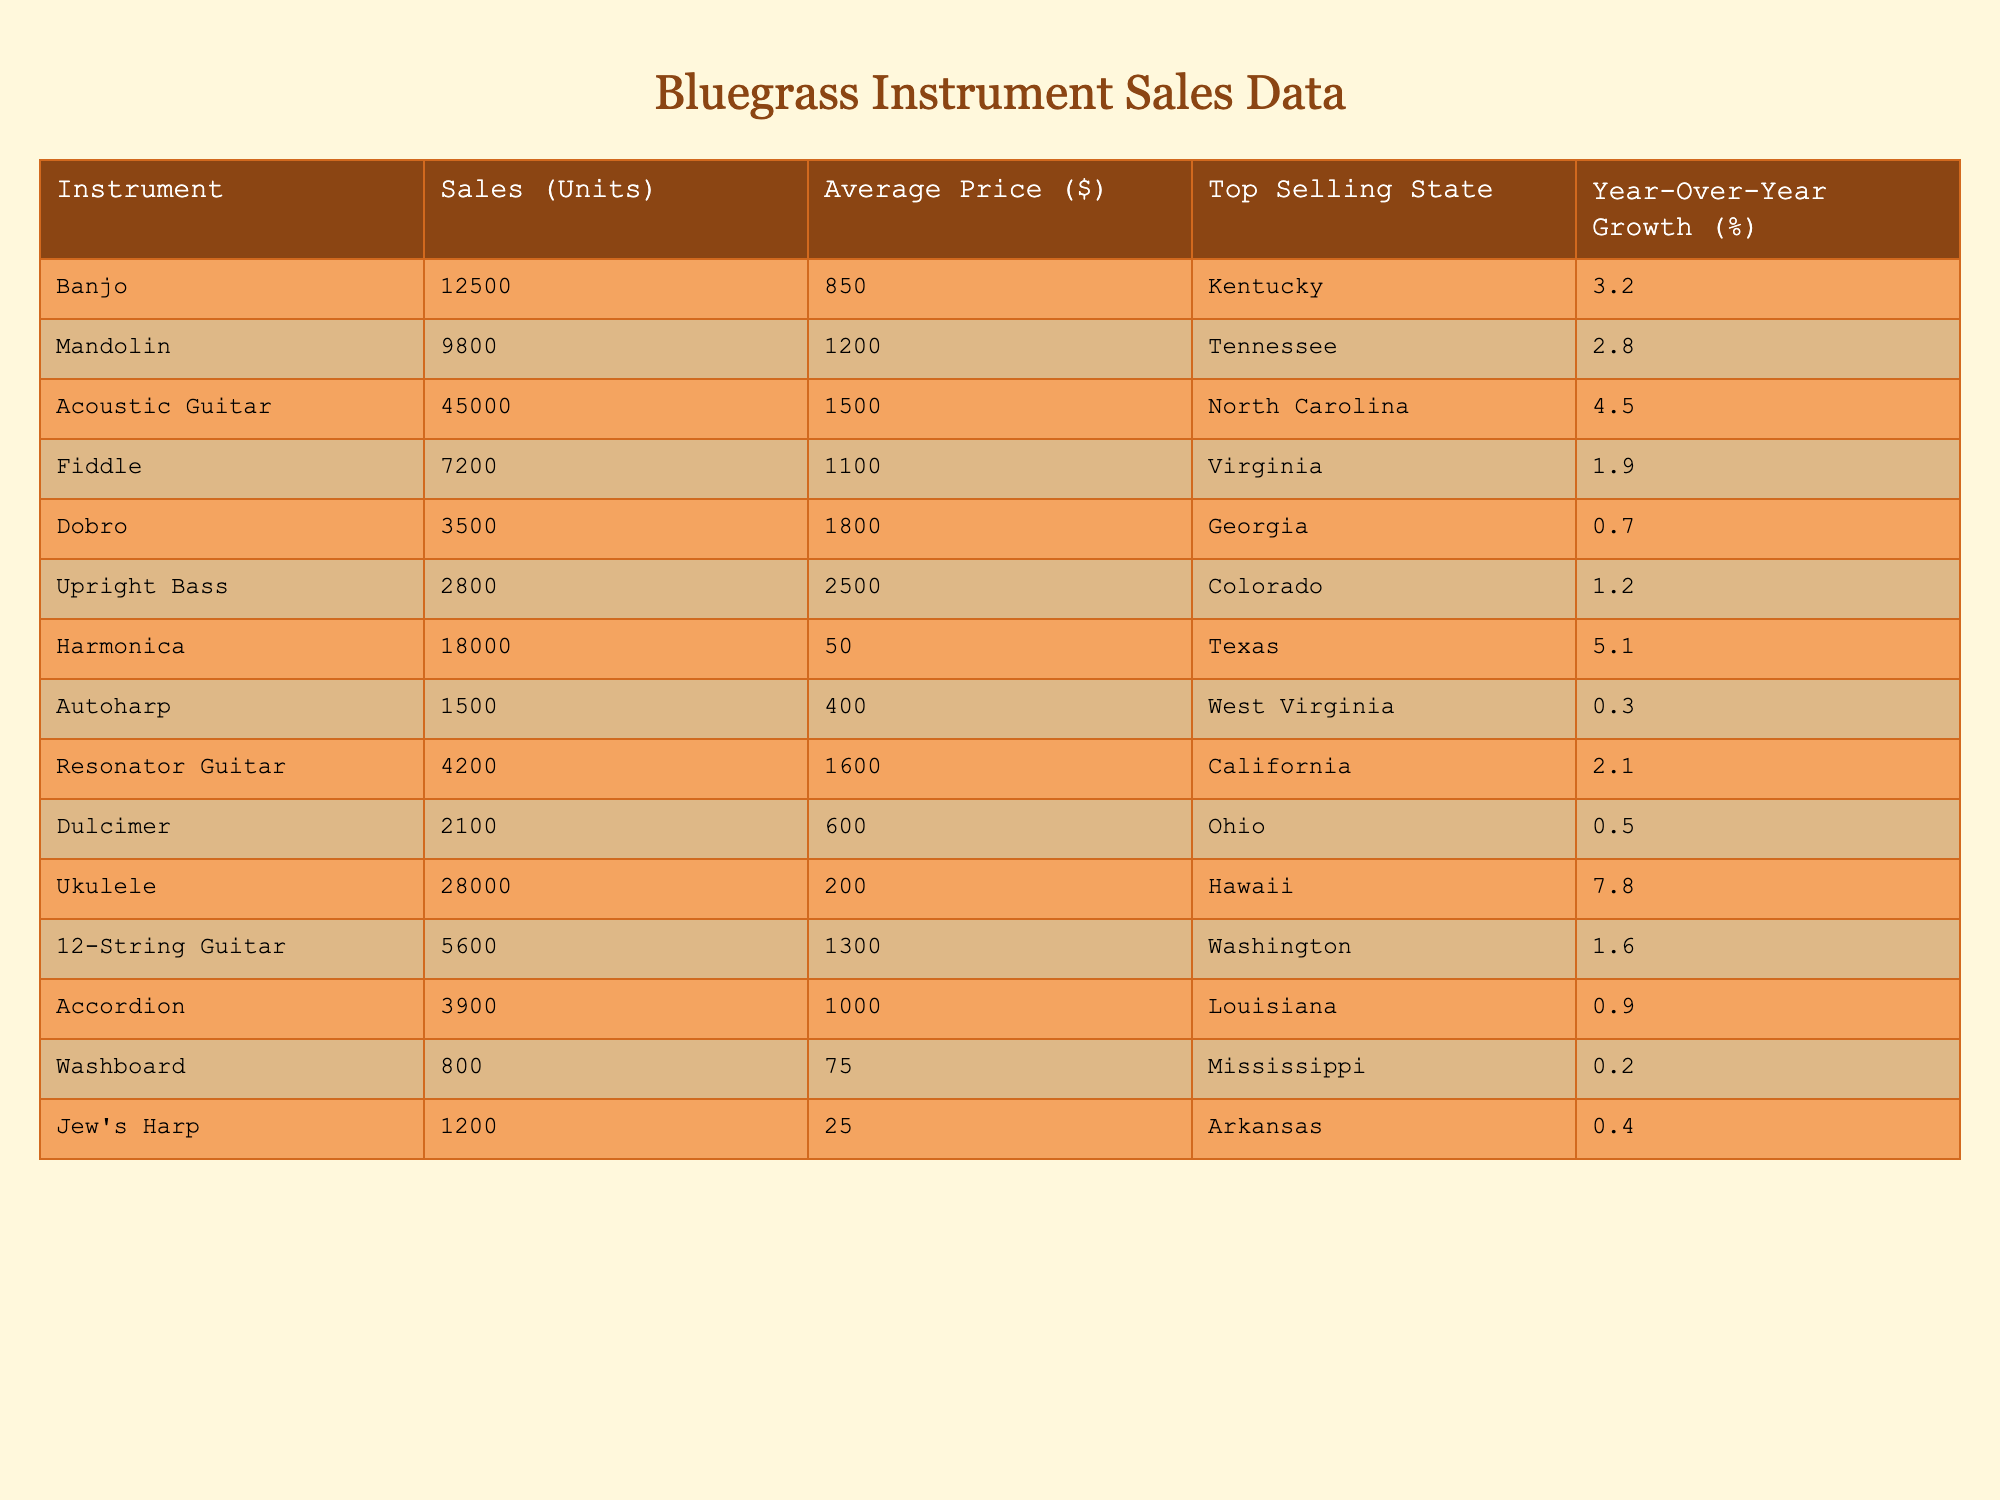What is the total number of units sold for bluegrass instruments? To find the total units sold, we sum up the Sales (Units) for all instruments: 12500 (Banjo) + 9800 (Mandolin) + 45000 (Acoustic Guitar) + 7200 (Fiddle) + 3500 (Dobro) + 2800 (Upright Bass) + 18000 (Harmonica) + 1500 (Autoharp) + 4200 (Resonator Guitar) + 2100 (Dulcimer) + 28000 (Ukulele) + 5600 (12-String Guitar) + 3900 (Accordion) + 800 (Washboard) + 1200 (Jew's Harp) = 117,900 units
Answer: 117900 Which instrument has the highest average price? By examining the Average Price ($) column, we see the Upright Bass has the highest price at $2500 compared to the other instruments.
Answer: Upright Bass What is the year-over-year growth percentage of the Ukulele? The year-over-year growth percentage of the Ukulele is listed in the table as 7.8%.
Answer: 7.8% How many more units were sold for the Acoustic Guitar than the Mandolin? To find the difference, we subtract the units sold for the Mandolin (9800) from the Acoustic Guitar (45000): 45000 - 9800 = 35200.
Answer: 35200 In which state was the Fiddle the top-selling instrument? The top-selling state for the Fiddle is given as Virginia.
Answer: Virginia Which instrument has the lowest units sold, and how many units were sold? The instrument with the lowest units sold is the Washboard with 800 units sold, as indicated in the Sales (Units) column.
Answer: Washboard, 800 What is the average price of all the instruments listed in the table? To calculate the average price, we sum up all the Average Prices and divide by the number of instruments: (850 + 1200 + 1500 + 1100 + 1800 + 2500 + 50 + 400 + 1600 + 600 + 200 + 1300 + 1000 + 75 + 25) / 15 = 860.
Answer: 860 Which two instruments combined had over 20,000 units sold? If we look at the units sold, Acoustic Guitar (45000) and Harmonica (18000) together have 63000 units sold (45000 + 18000 = 63000), which exceeds 20000.
Answer: Acoustic Guitar and Harmonica Is the year-over-year growth for Dobro greater than that of Fiddle? The year-over-year growth for Dobro is 0.7% and for Fiddle, it is 1.9%. Since 0.7% is less than 1.9%, the statement is false.
Answer: No What is the total amount of sales (in dollars) for the Harmonica? To calculate this, we multiply the number of units sold (18000) by the average price ($50): 18000 * 50 = 900000.
Answer: 900000 